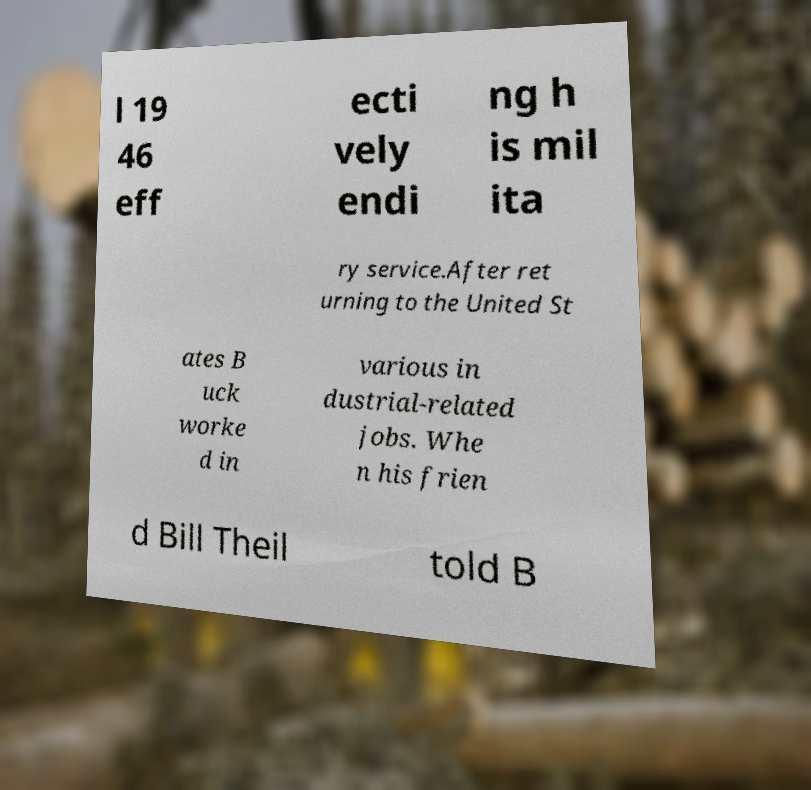There's text embedded in this image that I need extracted. Can you transcribe it verbatim? l 19 46 eff ecti vely endi ng h is mil ita ry service.After ret urning to the United St ates B uck worke d in various in dustrial-related jobs. Whe n his frien d Bill Theil told B 